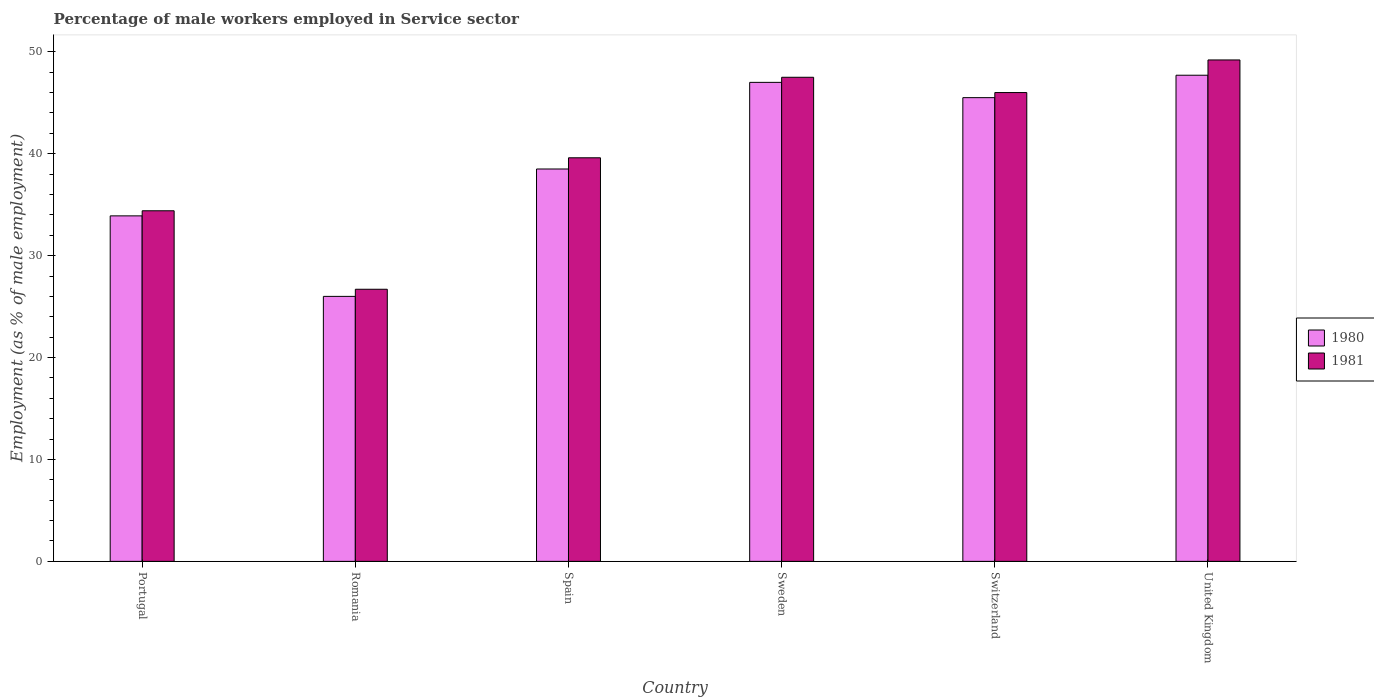How many different coloured bars are there?
Your answer should be compact. 2. How many groups of bars are there?
Ensure brevity in your answer.  6. Are the number of bars on each tick of the X-axis equal?
Offer a very short reply. Yes. What is the percentage of male workers employed in Service sector in 1980 in United Kingdom?
Ensure brevity in your answer.  47.7. Across all countries, what is the maximum percentage of male workers employed in Service sector in 1981?
Offer a very short reply. 49.2. In which country was the percentage of male workers employed in Service sector in 1981 minimum?
Offer a very short reply. Romania. What is the total percentage of male workers employed in Service sector in 1981 in the graph?
Keep it short and to the point. 243.4. What is the difference between the percentage of male workers employed in Service sector in 1980 in Sweden and that in United Kingdom?
Offer a terse response. -0.7. What is the difference between the percentage of male workers employed in Service sector in 1980 in Switzerland and the percentage of male workers employed in Service sector in 1981 in Spain?
Your answer should be very brief. 5.9. What is the average percentage of male workers employed in Service sector in 1981 per country?
Provide a short and direct response. 40.57. In how many countries, is the percentage of male workers employed in Service sector in 1980 greater than 26 %?
Your response must be concise. 5. What is the ratio of the percentage of male workers employed in Service sector in 1980 in Portugal to that in Spain?
Make the answer very short. 0.88. What is the difference between the highest and the second highest percentage of male workers employed in Service sector in 1981?
Make the answer very short. 3.2. What is the difference between the highest and the lowest percentage of male workers employed in Service sector in 1980?
Your answer should be compact. 21.7. What does the 1st bar from the left in United Kingdom represents?
Your answer should be very brief. 1980. What does the 1st bar from the right in United Kingdom represents?
Your answer should be compact. 1981. How many bars are there?
Offer a terse response. 12. Are all the bars in the graph horizontal?
Provide a short and direct response. No. What is the difference between two consecutive major ticks on the Y-axis?
Keep it short and to the point. 10. Are the values on the major ticks of Y-axis written in scientific E-notation?
Offer a very short reply. No. Does the graph contain any zero values?
Your response must be concise. No. Does the graph contain grids?
Provide a short and direct response. No. Where does the legend appear in the graph?
Your answer should be very brief. Center right. How many legend labels are there?
Your response must be concise. 2. How are the legend labels stacked?
Make the answer very short. Vertical. What is the title of the graph?
Provide a short and direct response. Percentage of male workers employed in Service sector. What is the label or title of the X-axis?
Your response must be concise. Country. What is the label or title of the Y-axis?
Your answer should be compact. Employment (as % of male employment). What is the Employment (as % of male employment) of 1980 in Portugal?
Ensure brevity in your answer.  33.9. What is the Employment (as % of male employment) in 1981 in Portugal?
Provide a succinct answer. 34.4. What is the Employment (as % of male employment) in 1981 in Romania?
Provide a succinct answer. 26.7. What is the Employment (as % of male employment) in 1980 in Spain?
Provide a short and direct response. 38.5. What is the Employment (as % of male employment) in 1981 in Spain?
Give a very brief answer. 39.6. What is the Employment (as % of male employment) in 1981 in Sweden?
Your answer should be very brief. 47.5. What is the Employment (as % of male employment) in 1980 in Switzerland?
Provide a succinct answer. 45.5. What is the Employment (as % of male employment) of 1981 in Switzerland?
Offer a terse response. 46. What is the Employment (as % of male employment) in 1980 in United Kingdom?
Make the answer very short. 47.7. What is the Employment (as % of male employment) in 1981 in United Kingdom?
Give a very brief answer. 49.2. Across all countries, what is the maximum Employment (as % of male employment) of 1980?
Offer a very short reply. 47.7. Across all countries, what is the maximum Employment (as % of male employment) in 1981?
Provide a succinct answer. 49.2. Across all countries, what is the minimum Employment (as % of male employment) in 1980?
Your answer should be compact. 26. Across all countries, what is the minimum Employment (as % of male employment) of 1981?
Ensure brevity in your answer.  26.7. What is the total Employment (as % of male employment) of 1980 in the graph?
Your response must be concise. 238.6. What is the total Employment (as % of male employment) of 1981 in the graph?
Provide a short and direct response. 243.4. What is the difference between the Employment (as % of male employment) in 1980 in Portugal and that in Romania?
Give a very brief answer. 7.9. What is the difference between the Employment (as % of male employment) in 1981 in Portugal and that in Romania?
Offer a terse response. 7.7. What is the difference between the Employment (as % of male employment) of 1981 in Portugal and that in United Kingdom?
Keep it short and to the point. -14.8. What is the difference between the Employment (as % of male employment) in 1981 in Romania and that in Spain?
Provide a short and direct response. -12.9. What is the difference between the Employment (as % of male employment) in 1981 in Romania and that in Sweden?
Make the answer very short. -20.8. What is the difference between the Employment (as % of male employment) of 1980 in Romania and that in Switzerland?
Your answer should be compact. -19.5. What is the difference between the Employment (as % of male employment) of 1981 in Romania and that in Switzerland?
Your answer should be compact. -19.3. What is the difference between the Employment (as % of male employment) of 1980 in Romania and that in United Kingdom?
Offer a terse response. -21.7. What is the difference between the Employment (as % of male employment) of 1981 in Romania and that in United Kingdom?
Offer a terse response. -22.5. What is the difference between the Employment (as % of male employment) of 1980 in Spain and that in Sweden?
Offer a terse response. -8.5. What is the difference between the Employment (as % of male employment) of 1981 in Spain and that in Switzerland?
Your response must be concise. -6.4. What is the difference between the Employment (as % of male employment) in 1980 in Spain and that in United Kingdom?
Ensure brevity in your answer.  -9.2. What is the difference between the Employment (as % of male employment) in 1981 in Sweden and that in Switzerland?
Offer a very short reply. 1.5. What is the difference between the Employment (as % of male employment) in 1981 in Sweden and that in United Kingdom?
Offer a very short reply. -1.7. What is the difference between the Employment (as % of male employment) of 1980 in Switzerland and that in United Kingdom?
Make the answer very short. -2.2. What is the difference between the Employment (as % of male employment) in 1980 in Portugal and the Employment (as % of male employment) in 1981 in Spain?
Provide a short and direct response. -5.7. What is the difference between the Employment (as % of male employment) in 1980 in Portugal and the Employment (as % of male employment) in 1981 in Switzerland?
Keep it short and to the point. -12.1. What is the difference between the Employment (as % of male employment) in 1980 in Portugal and the Employment (as % of male employment) in 1981 in United Kingdom?
Provide a succinct answer. -15.3. What is the difference between the Employment (as % of male employment) of 1980 in Romania and the Employment (as % of male employment) of 1981 in Spain?
Make the answer very short. -13.6. What is the difference between the Employment (as % of male employment) of 1980 in Romania and the Employment (as % of male employment) of 1981 in Sweden?
Provide a succinct answer. -21.5. What is the difference between the Employment (as % of male employment) of 1980 in Romania and the Employment (as % of male employment) of 1981 in Switzerland?
Provide a short and direct response. -20. What is the difference between the Employment (as % of male employment) in 1980 in Romania and the Employment (as % of male employment) in 1981 in United Kingdom?
Your response must be concise. -23.2. What is the difference between the Employment (as % of male employment) of 1980 in Spain and the Employment (as % of male employment) of 1981 in Switzerland?
Keep it short and to the point. -7.5. What is the difference between the Employment (as % of male employment) in 1980 in Sweden and the Employment (as % of male employment) in 1981 in Switzerland?
Offer a terse response. 1. What is the difference between the Employment (as % of male employment) in 1980 in Switzerland and the Employment (as % of male employment) in 1981 in United Kingdom?
Keep it short and to the point. -3.7. What is the average Employment (as % of male employment) in 1980 per country?
Offer a terse response. 39.77. What is the average Employment (as % of male employment) in 1981 per country?
Offer a terse response. 40.57. What is the difference between the Employment (as % of male employment) of 1980 and Employment (as % of male employment) of 1981 in Portugal?
Provide a succinct answer. -0.5. What is the difference between the Employment (as % of male employment) of 1980 and Employment (as % of male employment) of 1981 in Romania?
Give a very brief answer. -0.7. What is the difference between the Employment (as % of male employment) of 1980 and Employment (as % of male employment) of 1981 in Sweden?
Your answer should be compact. -0.5. What is the difference between the Employment (as % of male employment) of 1980 and Employment (as % of male employment) of 1981 in United Kingdom?
Ensure brevity in your answer.  -1.5. What is the ratio of the Employment (as % of male employment) of 1980 in Portugal to that in Romania?
Offer a very short reply. 1.3. What is the ratio of the Employment (as % of male employment) of 1981 in Portugal to that in Romania?
Make the answer very short. 1.29. What is the ratio of the Employment (as % of male employment) in 1980 in Portugal to that in Spain?
Your response must be concise. 0.88. What is the ratio of the Employment (as % of male employment) of 1981 in Portugal to that in Spain?
Provide a succinct answer. 0.87. What is the ratio of the Employment (as % of male employment) of 1980 in Portugal to that in Sweden?
Your answer should be compact. 0.72. What is the ratio of the Employment (as % of male employment) in 1981 in Portugal to that in Sweden?
Provide a short and direct response. 0.72. What is the ratio of the Employment (as % of male employment) in 1980 in Portugal to that in Switzerland?
Your response must be concise. 0.75. What is the ratio of the Employment (as % of male employment) in 1981 in Portugal to that in Switzerland?
Give a very brief answer. 0.75. What is the ratio of the Employment (as % of male employment) of 1980 in Portugal to that in United Kingdom?
Provide a succinct answer. 0.71. What is the ratio of the Employment (as % of male employment) of 1981 in Portugal to that in United Kingdom?
Provide a short and direct response. 0.7. What is the ratio of the Employment (as % of male employment) in 1980 in Romania to that in Spain?
Offer a terse response. 0.68. What is the ratio of the Employment (as % of male employment) in 1981 in Romania to that in Spain?
Provide a succinct answer. 0.67. What is the ratio of the Employment (as % of male employment) in 1980 in Romania to that in Sweden?
Offer a terse response. 0.55. What is the ratio of the Employment (as % of male employment) in 1981 in Romania to that in Sweden?
Provide a short and direct response. 0.56. What is the ratio of the Employment (as % of male employment) in 1980 in Romania to that in Switzerland?
Offer a very short reply. 0.57. What is the ratio of the Employment (as % of male employment) of 1981 in Romania to that in Switzerland?
Provide a succinct answer. 0.58. What is the ratio of the Employment (as % of male employment) in 1980 in Romania to that in United Kingdom?
Ensure brevity in your answer.  0.55. What is the ratio of the Employment (as % of male employment) of 1981 in Romania to that in United Kingdom?
Your answer should be very brief. 0.54. What is the ratio of the Employment (as % of male employment) in 1980 in Spain to that in Sweden?
Ensure brevity in your answer.  0.82. What is the ratio of the Employment (as % of male employment) in 1981 in Spain to that in Sweden?
Your answer should be compact. 0.83. What is the ratio of the Employment (as % of male employment) in 1980 in Spain to that in Switzerland?
Keep it short and to the point. 0.85. What is the ratio of the Employment (as % of male employment) in 1981 in Spain to that in Switzerland?
Make the answer very short. 0.86. What is the ratio of the Employment (as % of male employment) of 1980 in Spain to that in United Kingdom?
Offer a terse response. 0.81. What is the ratio of the Employment (as % of male employment) in 1981 in Spain to that in United Kingdom?
Offer a very short reply. 0.8. What is the ratio of the Employment (as % of male employment) of 1980 in Sweden to that in Switzerland?
Provide a succinct answer. 1.03. What is the ratio of the Employment (as % of male employment) of 1981 in Sweden to that in Switzerland?
Make the answer very short. 1.03. What is the ratio of the Employment (as % of male employment) of 1981 in Sweden to that in United Kingdom?
Give a very brief answer. 0.97. What is the ratio of the Employment (as % of male employment) of 1980 in Switzerland to that in United Kingdom?
Provide a short and direct response. 0.95. What is the ratio of the Employment (as % of male employment) in 1981 in Switzerland to that in United Kingdom?
Offer a very short reply. 0.94. What is the difference between the highest and the lowest Employment (as % of male employment) of 1980?
Give a very brief answer. 21.7. 